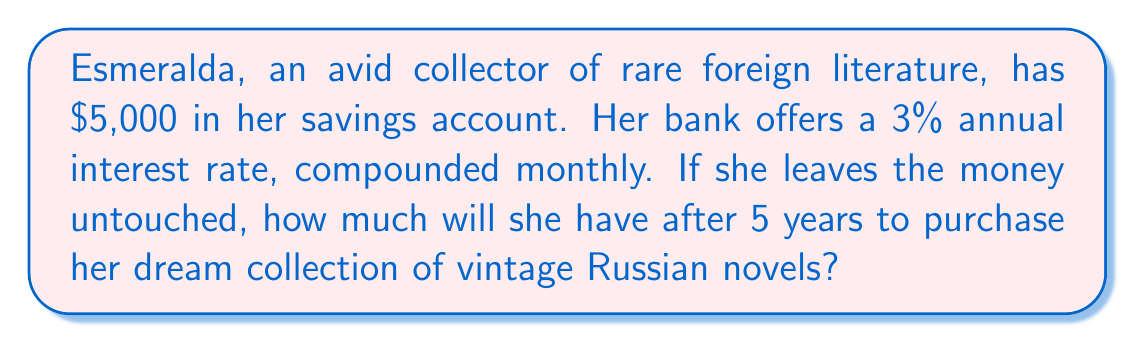Can you solve this math problem? To solve this problem, we'll use the compound interest formula:

$$A = P(1 + \frac{r}{n})^{nt}$$

Where:
$A$ = Final amount
$P$ = Principal (initial investment)
$r$ = Annual interest rate (in decimal form)
$n$ = Number of times interest is compounded per year
$t$ = Number of years

Given:
$P = \$5,000$
$r = 0.03$ (3% converted to decimal)
$n = 12$ (compounded monthly)
$t = 5$ years

Let's substitute these values into the formula:

$$A = 5000(1 + \frac{0.03}{12})^{12 \cdot 5}$$

$$A = 5000(1 + 0.0025)^{60}$$

$$A = 5000(1.0025)^{60}$$

Using a calculator or computer:

$$A = 5000 \cdot 1.161678$$

$$A = 5808.39$$
Answer: $5,808.39 